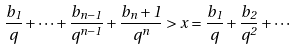<formula> <loc_0><loc_0><loc_500><loc_500>\frac { b _ { 1 } } { q } + \cdots + \frac { b _ { n - 1 } } { q ^ { n - 1 } } + \frac { b _ { n } + 1 } { q ^ { n } } > x = \frac { b _ { 1 } } { q } + \frac { b _ { 2 } } { q ^ { 2 } } + \cdots</formula> 